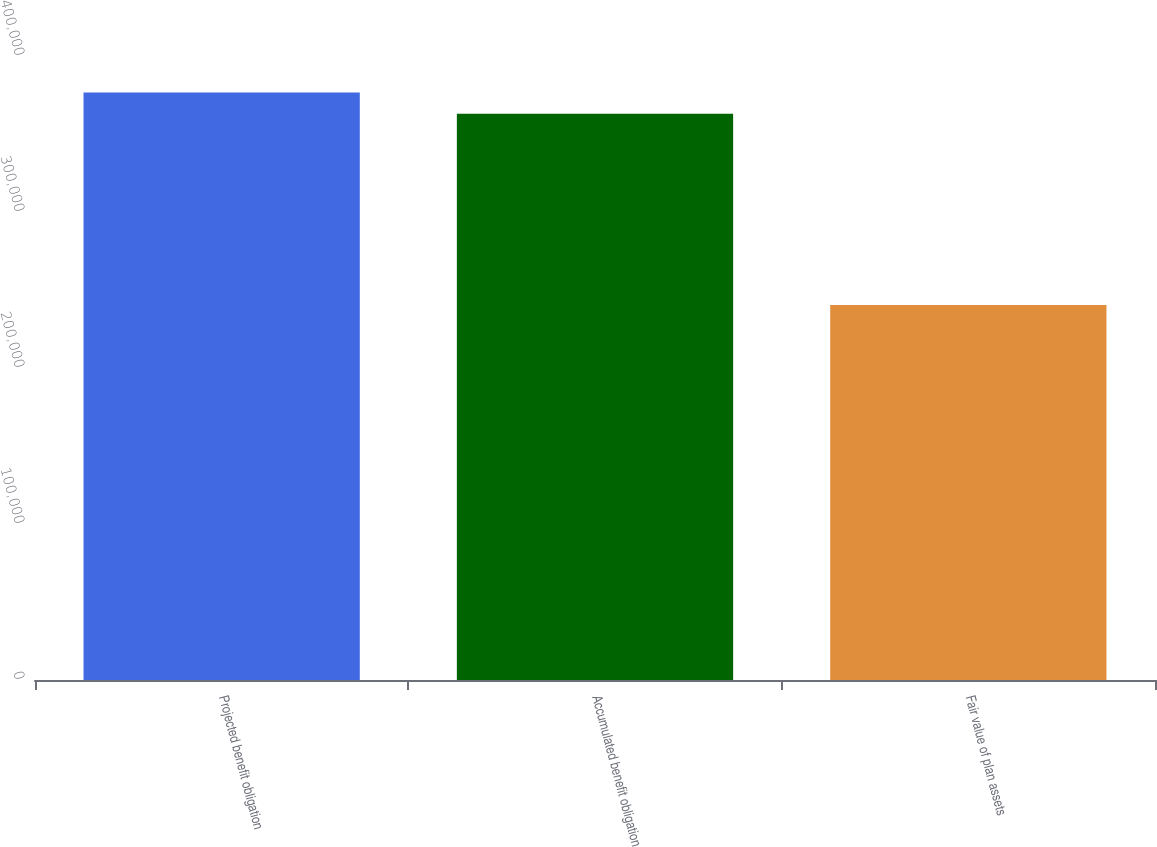Convert chart to OTSL. <chart><loc_0><loc_0><loc_500><loc_500><bar_chart><fcel>Projected benefit obligation<fcel>Accumulated benefit obligation<fcel>Fair value of plan assets<nl><fcel>376630<fcel>363015<fcel>240313<nl></chart> 